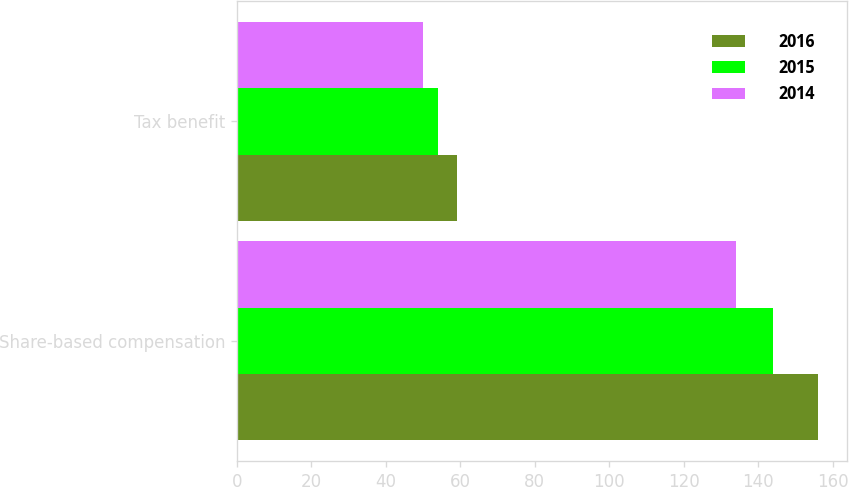Convert chart to OTSL. <chart><loc_0><loc_0><loc_500><loc_500><stacked_bar_chart><ecel><fcel>Share-based compensation<fcel>Tax benefit<nl><fcel>2016<fcel>156<fcel>59<nl><fcel>2015<fcel>144<fcel>54<nl><fcel>2014<fcel>134<fcel>50<nl></chart> 